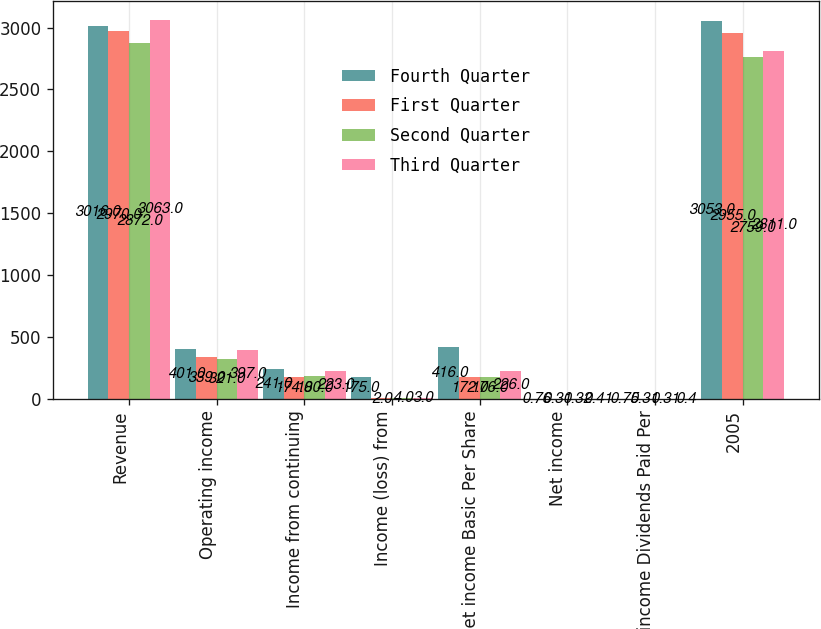Convert chart to OTSL. <chart><loc_0><loc_0><loc_500><loc_500><stacked_bar_chart><ecel><fcel>Revenue<fcel>Operating income<fcel>Income from continuing<fcel>Income (loss) from<fcel>Net income Basic Per Share<fcel>Net income<fcel>Net income Dividends Paid Per<fcel>2005<nl><fcel>Fourth Quarter<fcel>3016<fcel>401<fcel>241<fcel>175<fcel>416<fcel>0.76<fcel>0.75<fcel>3053<nl><fcel>First Quarter<fcel>2970<fcel>339<fcel>174<fcel>2<fcel>172<fcel>0.31<fcel>0.31<fcel>2955<nl><fcel>Second Quarter<fcel>2872<fcel>321<fcel>180<fcel>4<fcel>176<fcel>0.32<fcel>0.31<fcel>2759<nl><fcel>Third Quarter<fcel>3063<fcel>397<fcel>223<fcel>3<fcel>226<fcel>0.41<fcel>0.4<fcel>2811<nl></chart> 